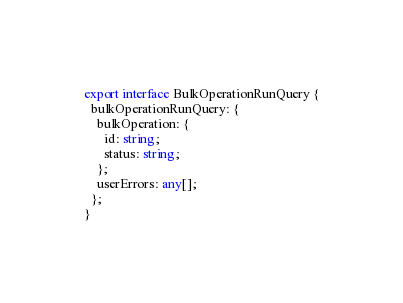Convert code to text. <code><loc_0><loc_0><loc_500><loc_500><_TypeScript_>export interface BulkOperationRunQuery {
  bulkOperationRunQuery: {
    bulkOperation: {
      id: string;
      status: string;
    };
    userErrors: any[];
  };
}
</code> 